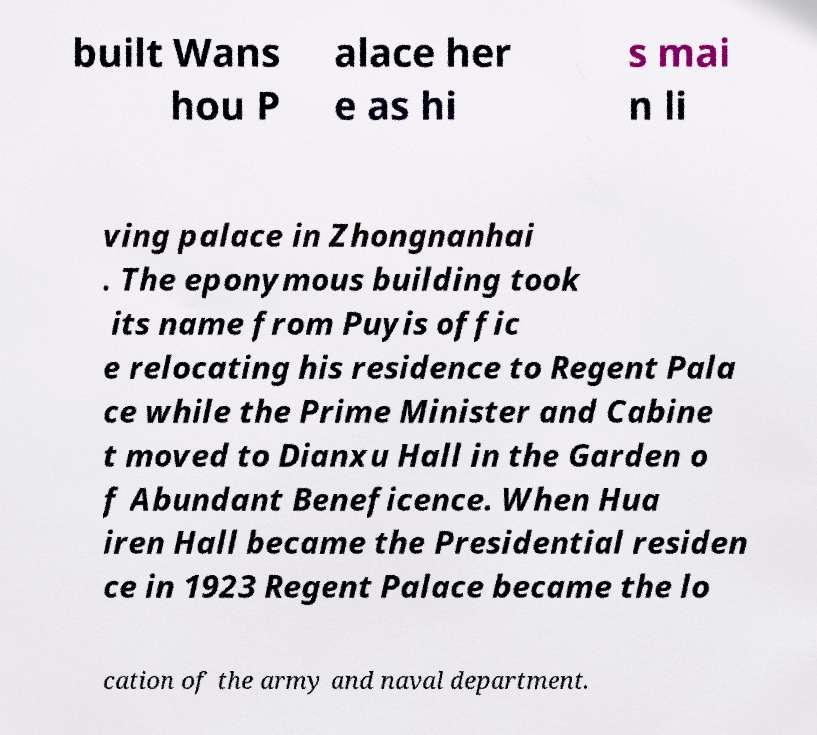Please read and relay the text visible in this image. What does it say? built Wans hou P alace her e as hi s mai n li ving palace in Zhongnanhai . The eponymous building took its name from Puyis offic e relocating his residence to Regent Pala ce while the Prime Minister and Cabine t moved to Dianxu Hall in the Garden o f Abundant Beneficence. When Hua iren Hall became the Presidential residen ce in 1923 Regent Palace became the lo cation of the army and naval department. 